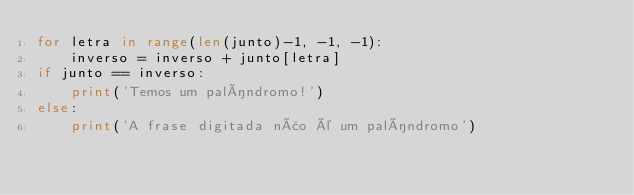Convert code to text. <code><loc_0><loc_0><loc_500><loc_500><_Python_>for letra in range(len(junto)-1, -1, -1):
    inverso = inverso + junto[letra]
if junto == inverso:
    print('Temos um palíndromo!')
else:
    print('A frase digitada não é um palíndromo')
</code> 